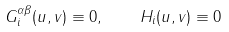<formula> <loc_0><loc_0><loc_500><loc_500>G _ { i } ^ { \alpha \beta } ( u , v ) \equiv 0 , \quad H _ { i } ( u , v ) \equiv 0</formula> 